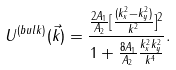<formula> <loc_0><loc_0><loc_500><loc_500>U ^ { ( b u l k ) } ( \vec { k } ) = \frac { \frac { 2 A _ { 1 } } { A _ { 2 } } [ \frac { ( k _ { x } ^ { 2 } - k _ { y } ^ { 2 } ) } { k ^ { 2 } } ] ^ { 2 } } { 1 + \frac { 8 A _ { 1 } } { A _ { 2 } } \frac { k _ { x } ^ { 2 } k _ { y } ^ { 2 } } { k ^ { 4 } } } .</formula> 